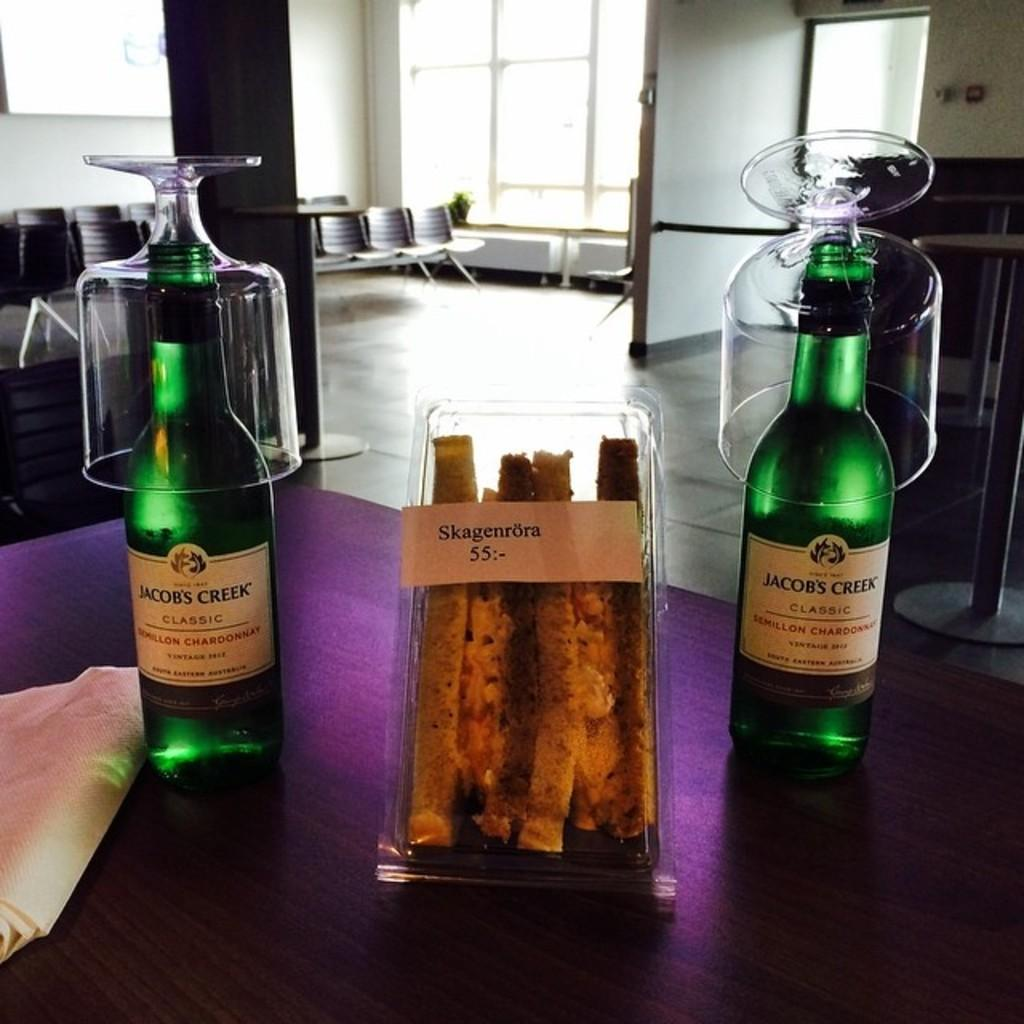<image>
Write a terse but informative summary of the picture. Two bottles of Jacobs Creek Chardonnay sitting on a table with glasses on top of them. 